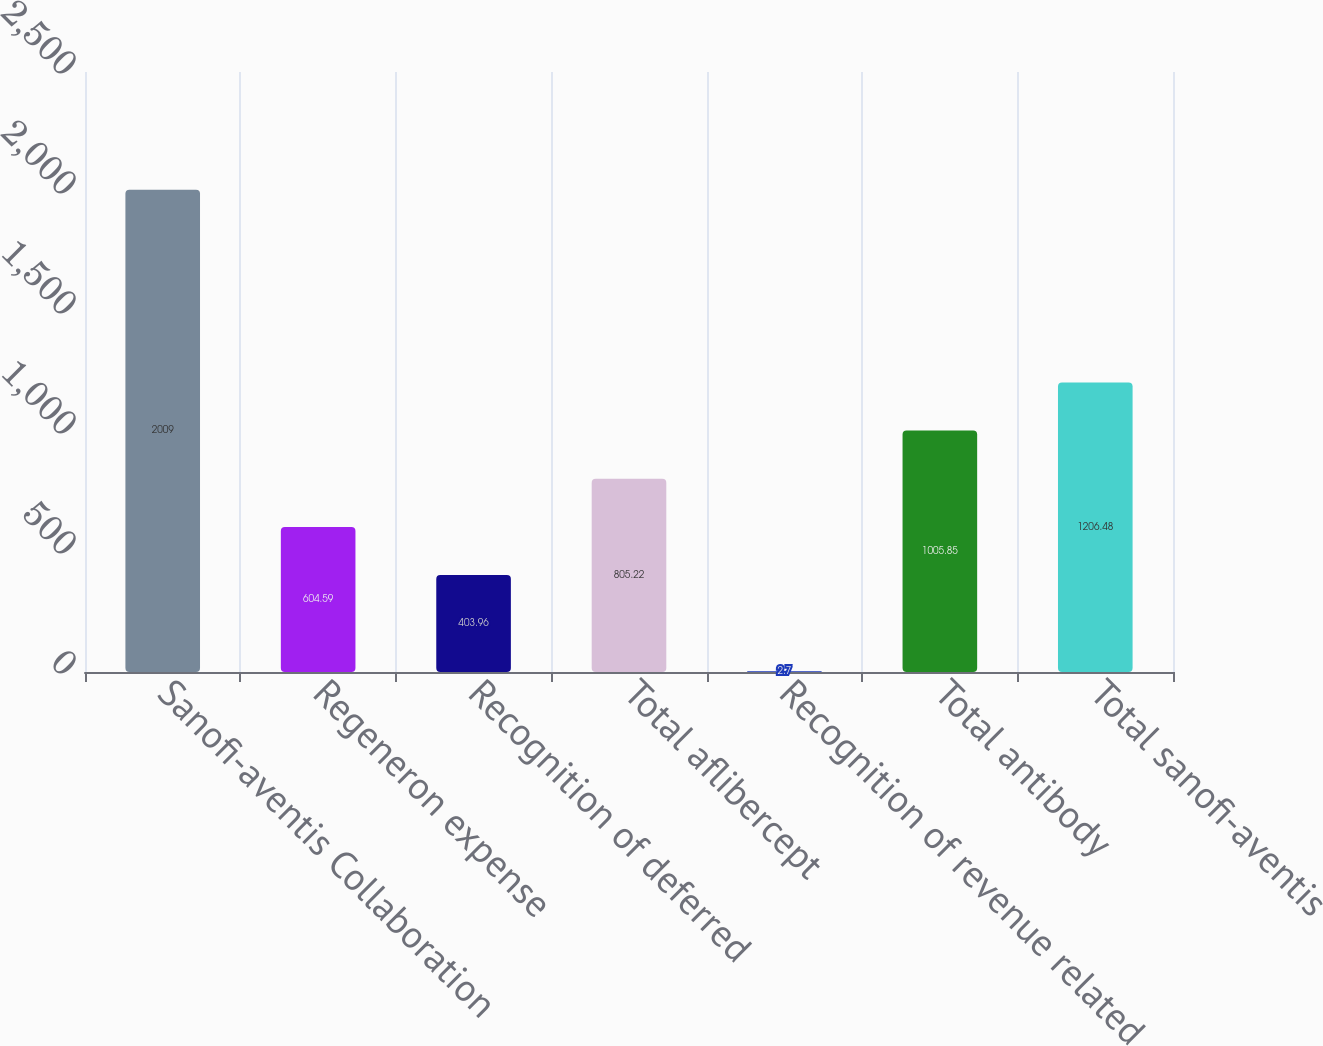Convert chart. <chart><loc_0><loc_0><loc_500><loc_500><bar_chart><fcel>Sanofi-aventis Collaboration<fcel>Regeneron expense<fcel>Recognition of deferred<fcel>Total aflibercept<fcel>Recognition of revenue related<fcel>Total antibody<fcel>Total sanofi-aventis<nl><fcel>2009<fcel>604.59<fcel>403.96<fcel>805.22<fcel>2.7<fcel>1005.85<fcel>1206.48<nl></chart> 